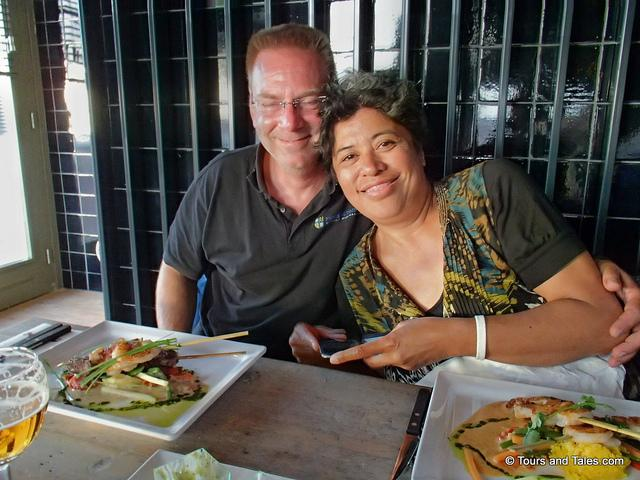What will this couple use to dine here? chopsticks 